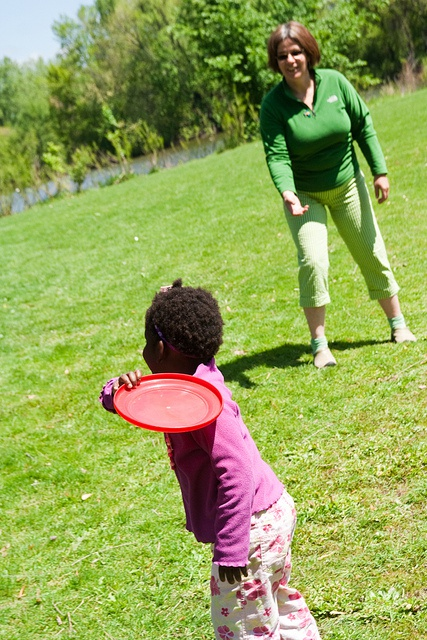Describe the objects in this image and their specific colors. I can see people in lavender, black, violet, and maroon tones, people in lavender, black, darkgreen, beige, and lightgreen tones, and frisbee in lavender, lightpink, red, salmon, and pink tones in this image. 